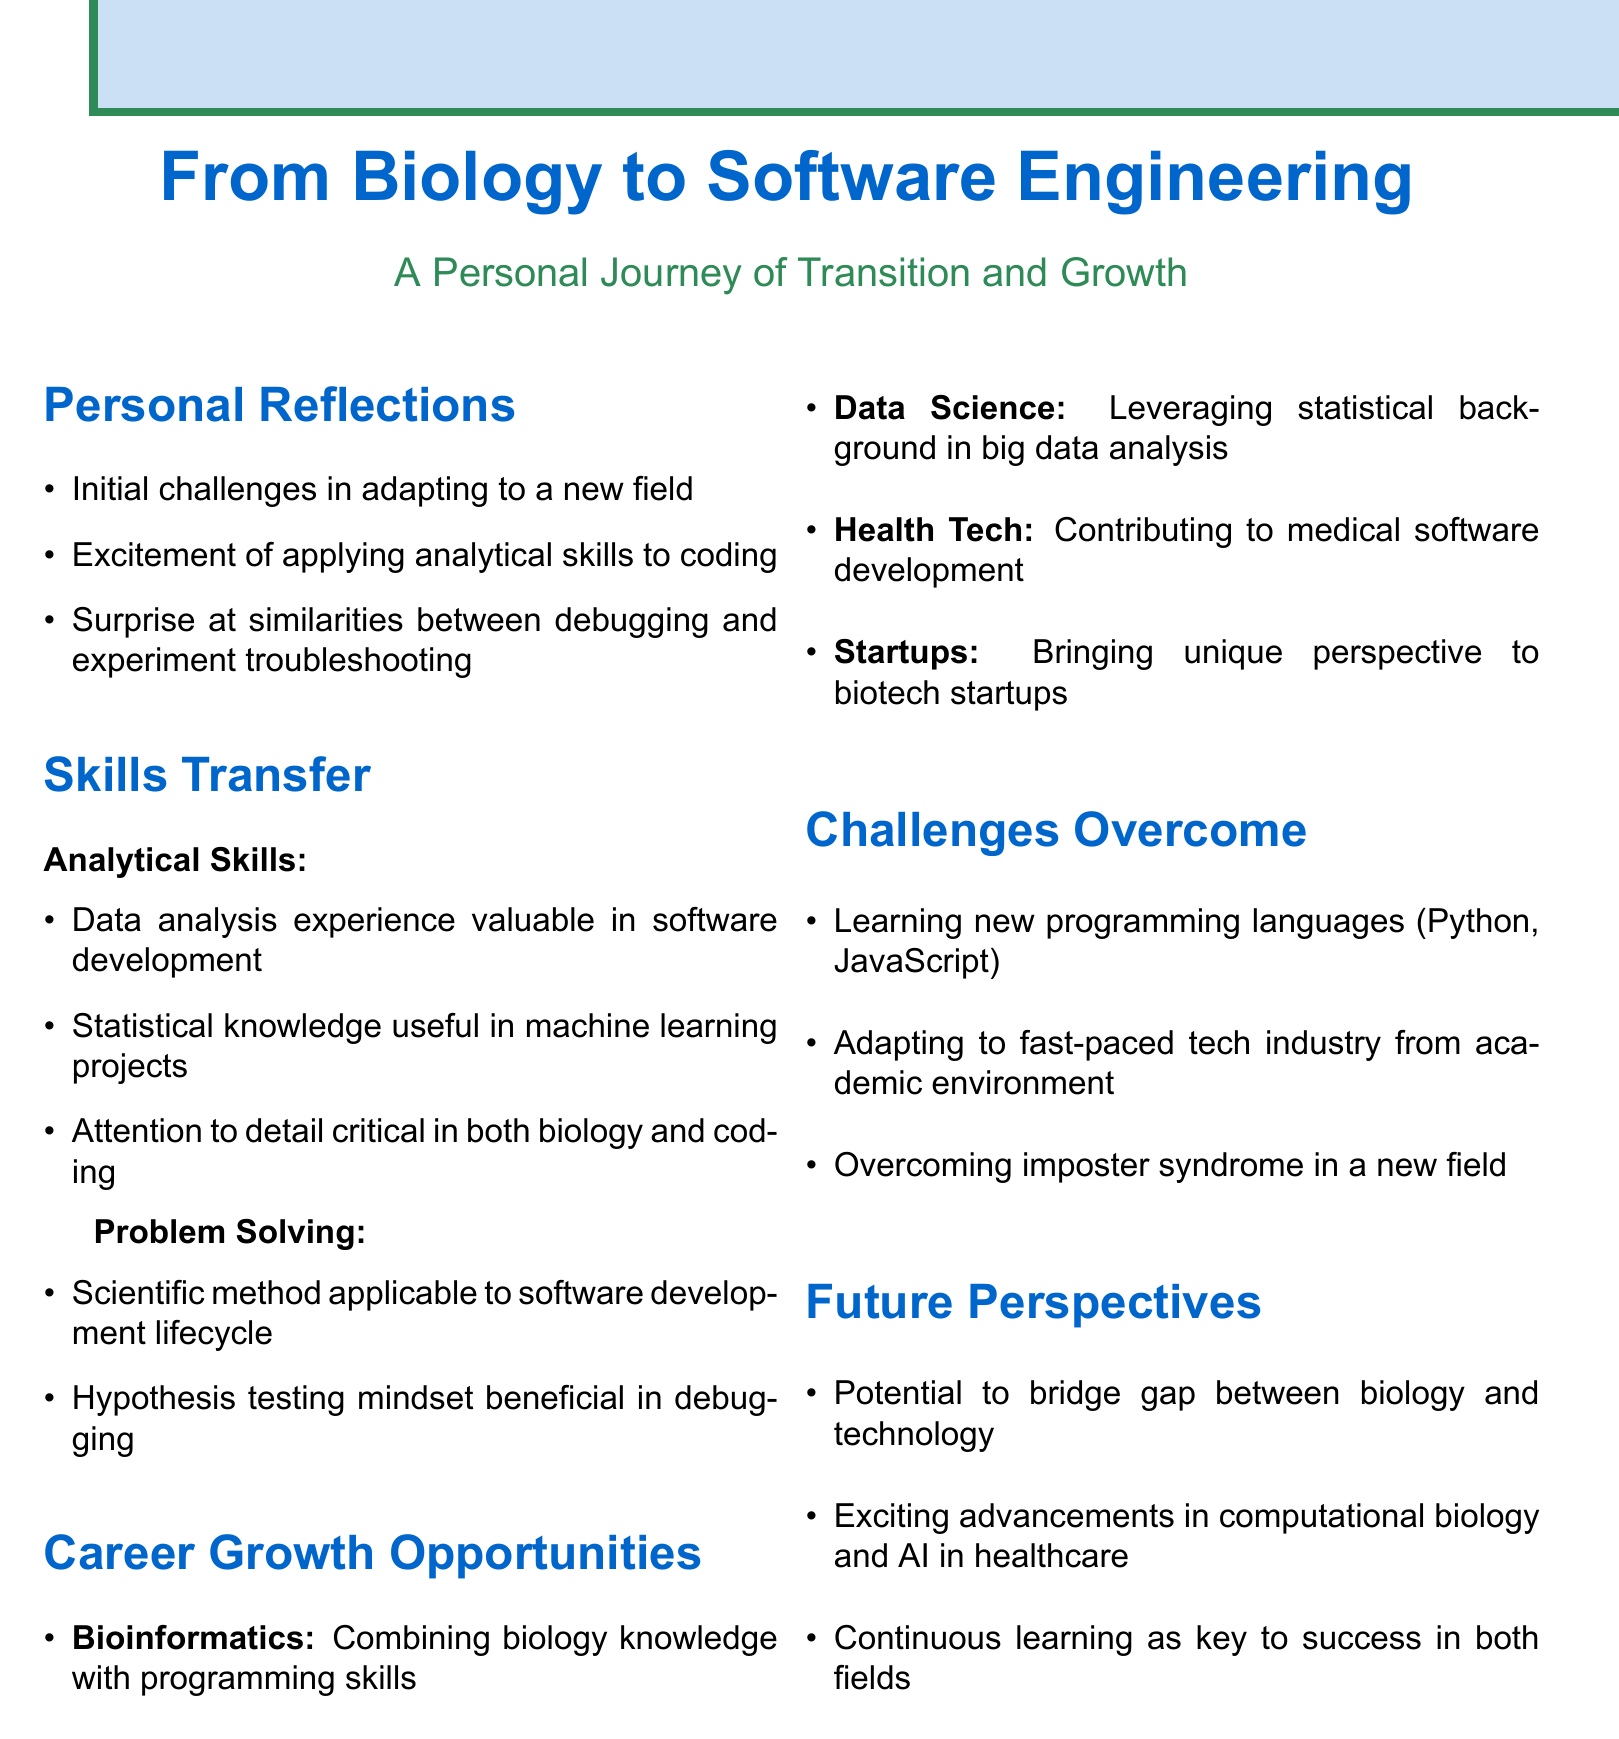what is the title of the document? The title of the document is found at the top and reflects the main theme.
Answer: From Biology to Software Engineering what are the initial challenges mentioned in the reflections? The document lists specifics under personal reflections representing fundamental obstacles encountered.
Answer: Initial challenges in adapting to a new field which programming languages are mentioned as challenges to learn? The document notes specific programming languages that posed a learning challenge.
Answer: Python, JavaScript what is one career growth opportunity related to programming skills? A specific field is associated with leveraging both biology knowledge and programming skills for career advancement.
Answer: Bioinformatics which mindset is considered beneficial in debugging? This term refers to an analytical approach derived from scientific practices that aids problem-solving in coding.
Answer: Hypothesis testing what is highlighted as critical in both biology and coding? The document emphasizes this common attribute as essential in ensuring precision in both fields.
Answer: Attention to detail what new industry does the transition involve? The document contrasts the previous academic environment with a different, more dynamic field.
Answer: Tech industry what is the potential future perspective mentioned? A concept is suggested that connects biological knowledge with technological advancements for future career paths.
Answer: Bridge gap between biology and technology 